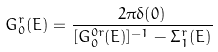Convert formula to latex. <formula><loc_0><loc_0><loc_500><loc_500>G ^ { r } _ { 0 } ( E ) = \frac { 2 \pi \delta ( 0 ) } { [ G ^ { 0 r } _ { 0 } ( E ) ] ^ { - 1 } - \Sigma ^ { r } _ { 1 } ( E ) }</formula> 